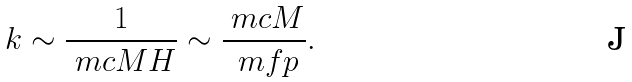Convert formula to latex. <formula><loc_0><loc_0><loc_500><loc_500>k \sim \frac { 1 } { \ m c { M } H } \sim \frac { \ m c { M } } { \ m f p } .</formula> 